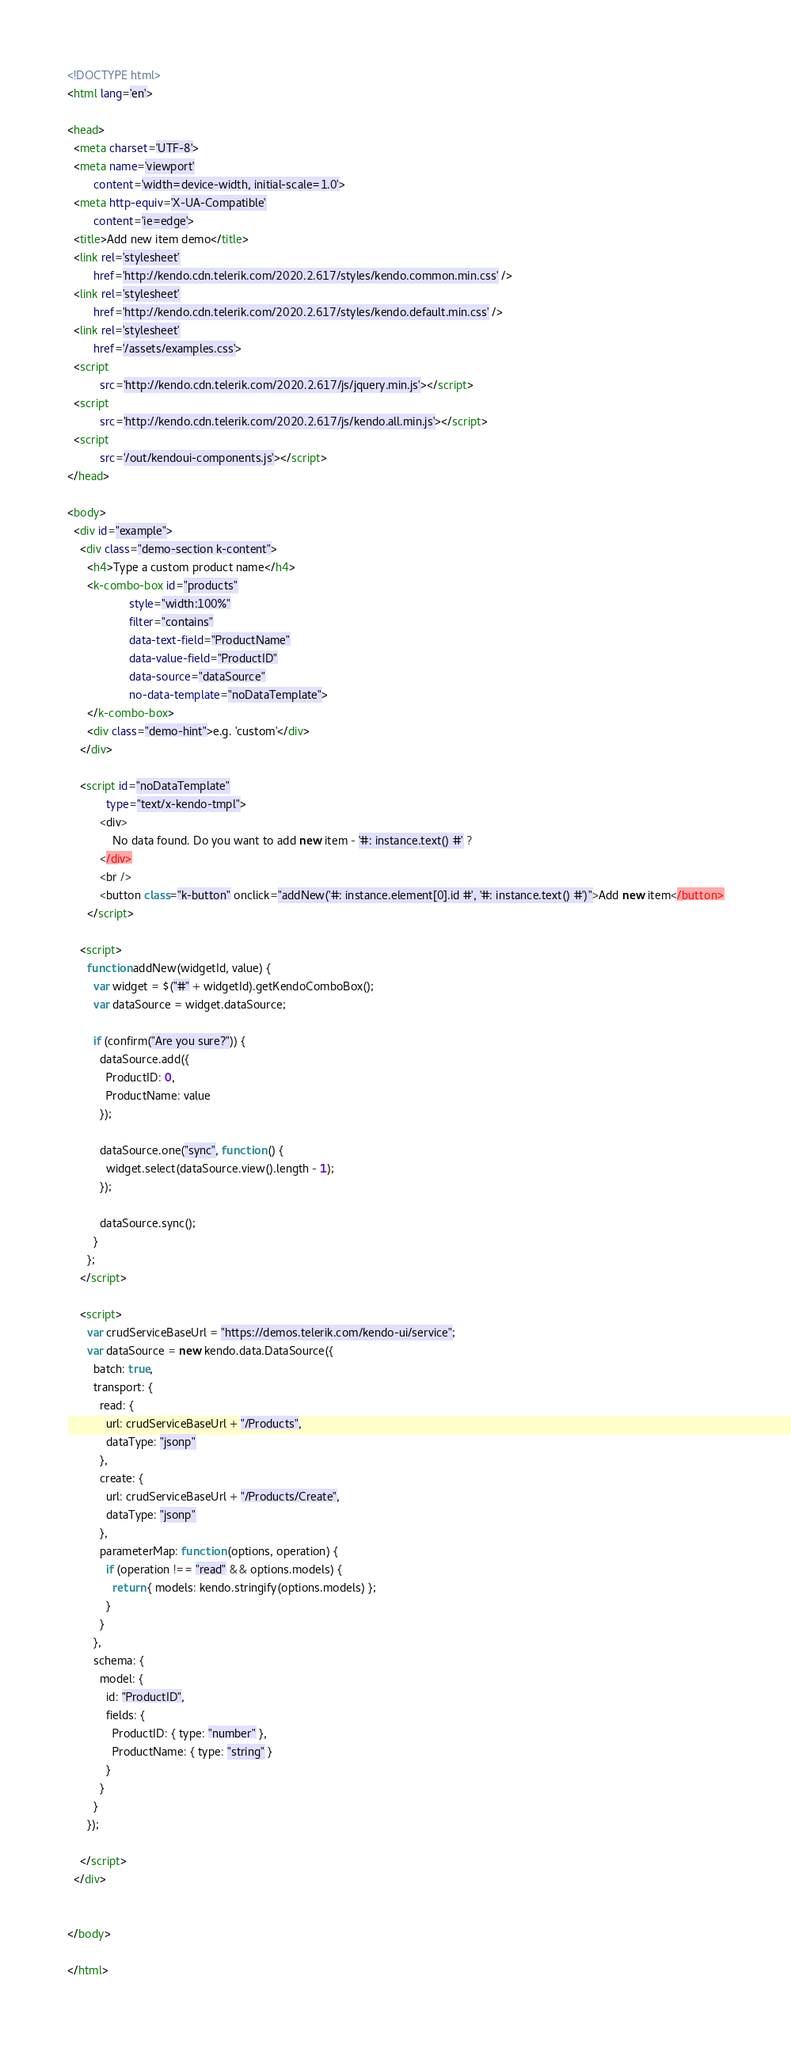Convert code to text. <code><loc_0><loc_0><loc_500><loc_500><_HTML_><!DOCTYPE html>
<html lang='en'>

<head>
  <meta charset='UTF-8'>
  <meta name='viewport'
        content='width=device-width, initial-scale=1.0'>
  <meta http-equiv='X-UA-Compatible'
        content='ie=edge'>
  <title>Add new item demo</title>
  <link rel='stylesheet'
        href='http://kendo.cdn.telerik.com/2020.2.617/styles/kendo.common.min.css' />
  <link rel='stylesheet'
        href='http://kendo.cdn.telerik.com/2020.2.617/styles/kendo.default.min.css' />
  <link rel='stylesheet'
        href='/assets/examples.css'>
  <script
          src='http://kendo.cdn.telerik.com/2020.2.617/js/jquery.min.js'></script>
  <script
          src='http://kendo.cdn.telerik.com/2020.2.617/js/kendo.all.min.js'></script>
  <script
          src='/out/kendoui-components.js'></script>
</head>

<body>
  <div id="example">
    <div class="demo-section k-content">
      <h4>Type a custom product name</h4>
      <k-combo-box id="products"
                   style="width:100%"
                   filter="contains"
                   data-text-field="ProductName"
                   data-value-field="ProductID"
                   data-source="dataSource"
                   no-data-template="noDataTemplate">
      </k-combo-box>
      <div class="demo-hint">e.g. 'custom'</div>
    </div>

    <script id="noDataTemplate"
            type="text/x-kendo-tmpl">
          <div>
              No data found. Do you want to add new item - '#: instance.text() #' ?
          </div>
          <br />
          <button class="k-button" onclick="addNew('#: instance.element[0].id #', '#: instance.text() #')">Add new item</button>
      </script>

    <script>
      function addNew(widgetId, value) {
        var widget = $("#" + widgetId).getKendoComboBox();
        var dataSource = widget.dataSource;

        if (confirm("Are you sure?")) {
          dataSource.add({
            ProductID: 0,
            ProductName: value
          });

          dataSource.one("sync", function () {
            widget.select(dataSource.view().length - 1);
          });

          dataSource.sync();
        }
      };
    </script>

    <script>
      var crudServiceBaseUrl = "https://demos.telerik.com/kendo-ui/service";
      var dataSource = new kendo.data.DataSource({
        batch: true,
        transport: {
          read: {
            url: crudServiceBaseUrl + "/Products",
            dataType: "jsonp"
          },
          create: {
            url: crudServiceBaseUrl + "/Products/Create",
            dataType: "jsonp"
          },
          parameterMap: function (options, operation) {
            if (operation !== "read" && options.models) {
              return { models: kendo.stringify(options.models) };
            }
          }
        },
        schema: {
          model: {
            id: "ProductID",
            fields: {
              ProductID: { type: "number" },
              ProductName: { type: "string" }
            }
          }
        }
      });

    </script>
  </div>


</body>

</html></code> 